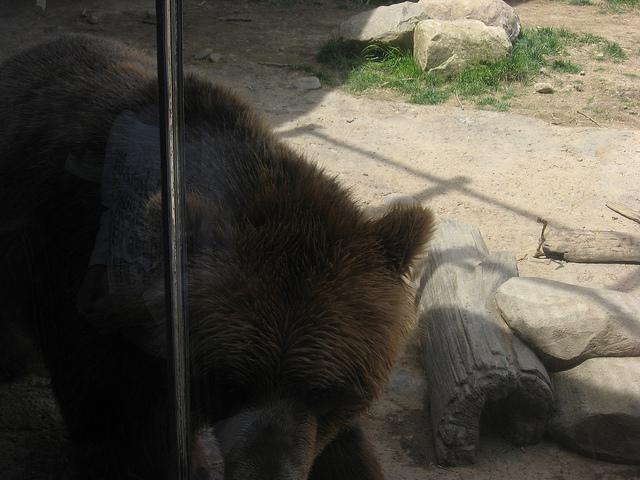What is the weather in the photo?
Write a very short answer. Sunny. What type of bear is this?
Quick response, please. Brown. Is someone feeding the bear?
Short answer required. No. What bear is this?
Write a very short answer. Brown. What type of animal is this?
Write a very short answer. Bear. Is the bear trying to escape?
Answer briefly. No. What animal is in the image?
Write a very short answer. Bear. Is this a dry climate or a rainy one?
Keep it brief. Dry. What is in front of the bear?
Quick response, please. Glass. Is the bear in the wild?
Quick response, please. No. What kind of bear is this?
Be succinct. Brown. Is this a grizzly bear?
Short answer required. Yes. Is there a log in the picture?
Write a very short answer. Yes. 